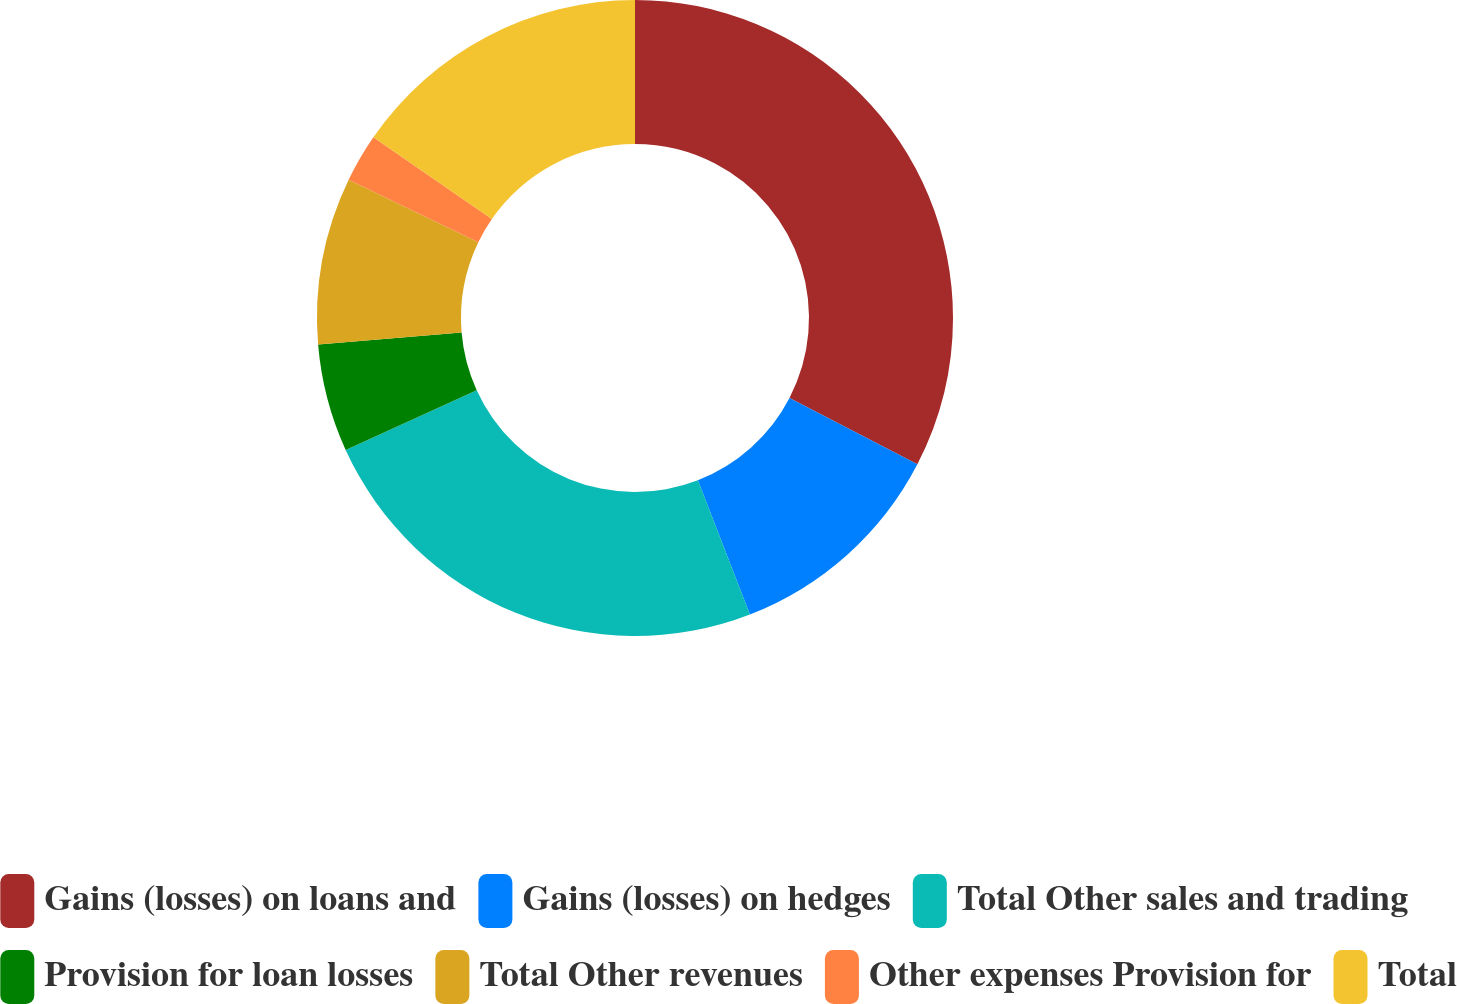Convert chart to OTSL. <chart><loc_0><loc_0><loc_500><loc_500><pie_chart><fcel>Gains (losses) on loans and<fcel>Gains (losses) on hedges<fcel>Total Other sales and trading<fcel>Provision for loan losses<fcel>Total Other revenues<fcel>Other expenses Provision for<fcel>Total<nl><fcel>32.61%<fcel>11.51%<fcel>24.08%<fcel>5.48%<fcel>8.49%<fcel>2.46%<fcel>15.38%<nl></chart> 